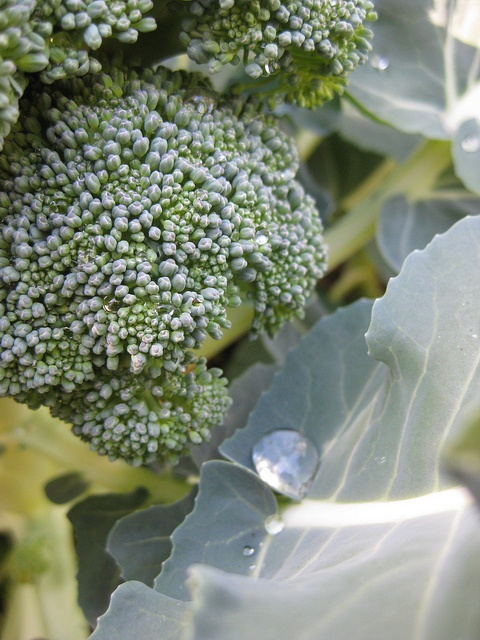Describe the objects in this image and their specific colors. I can see broccoli in green, darkgray, gray, black, and darkgreen tones and broccoli in green, black, darkgreen, gray, and darkgray tones in this image. 